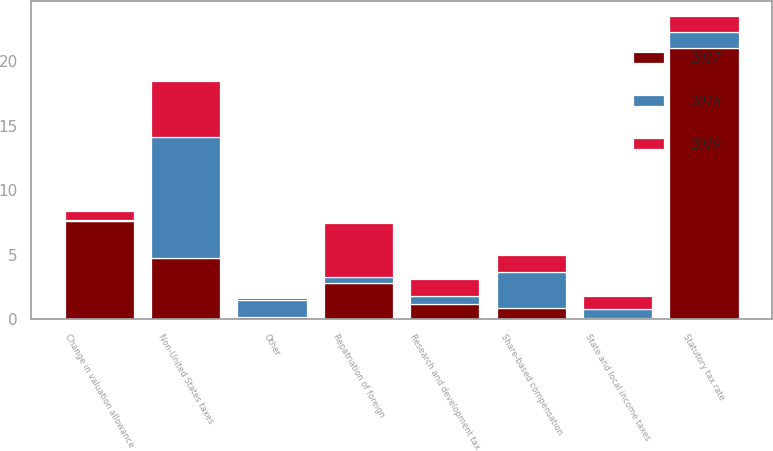<chart> <loc_0><loc_0><loc_500><loc_500><stacked_bar_chart><ecel><fcel>Statutory tax rate<fcel>State and local income taxes<fcel>Non-United States taxes<fcel>Repatriation of foreign<fcel>Change in valuation allowance<fcel>Share-based compensation<fcel>Research and development tax<fcel>Other<nl><fcel>2017<fcel>21<fcel>0.1<fcel>4.8<fcel>2.8<fcel>7.6<fcel>0.9<fcel>1.2<fcel>0.2<nl><fcel>2019<fcel>1.25<fcel>1<fcel>4.4<fcel>4.2<fcel>0.7<fcel>1.3<fcel>1.3<fcel>0.2<nl><fcel>2018<fcel>1.25<fcel>0.7<fcel>9.3<fcel>0.5<fcel>0.1<fcel>2.8<fcel>0.6<fcel>1.3<nl></chart> 